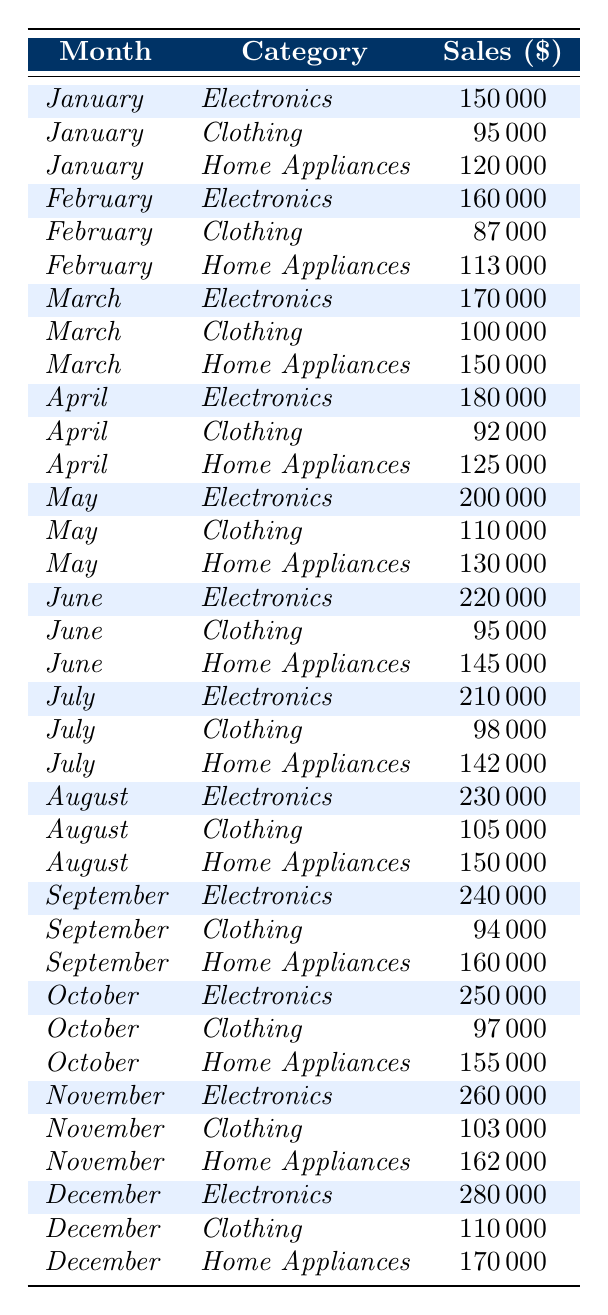What were the total sales for Electronics in June? The sales for Electronics in June are listed in the table as 220,000.
Answer: 220000 What is the sales figure for Home Appliances in December? The sales figure for Home Appliances in December is given as 170,000 according to the table.
Answer: 170000 Which product category had the highest sales in November? Comparing the sales in November, Electronics had 260,000, Clothing had 103,000, and Home Appliances had 162,000. Therefore, Electronics had the highest sales.
Answer: Electronics What were the average sales for Clothing from January to March? The sales figures for Clothing from January to March are 95,000, 87,000, and 100,000. Adding these gives 282,000. The average is 282,000 / 3 = 94,000.
Answer: 94000 Did sales for Home Appliances increase every month throughout the year? Looking at the sales figures for Home Appliances, they were 120,000 in January, 113,000 in February, 150,000 in March, 125,000 in April, 130,000 in May, 145,000 in June, 142,000 in July, 150,000 in August, 160,000 in September, 155,000 in October, 162,000 in November, and 170,000 in December. The sales fluctuate and do not increase every month, indicating a "No" answer.
Answer: No What was the percentage increase in sales for Electronics from July to October? For Electronics, sales were 210,000 in July and increased to 250,000 in October. The difference is 250,000 - 210,000 = 40,000. The percentage increase is (40,000 / 210,000) * 100 = approximately 19.05%.
Answer: 19.05% Which month had the lowest sales for Clothing during 2023, and what was that amount? The sales figures for Clothing are 95,000 in January, 87,000 in February, 100,000 in March, 92,000 in April, 110,000 in May, 95,000 in June, 98,000 in July, 105,000 in August, 94,000 in September, 97,000 in October, 103,000 in November, and 110,000 in December. The lowest sales occurred in February with 87,000.
Answer: February, 87000 Calculate the difference between the total sales of Electronics and Home Appliances in August. The total sales of Electronics in August was 230,000, and for Home Appliances, it was 150,000. The difference is 230,000 - 150,000 = 80,000.
Answer: 80000 Is it true that Clothing sales were consistently below 100,000 until May? The sales figures for Clothing in January (95,000), February (87,000), March (100,000), and April (92,000). January, February, and April are below 100,000, while March is exactly 100,000. Therefore, it is not true as March is not below.
Answer: No What was the highest sales figure for any product category in 2023, and which category achieved it? The highest sales figure in the table is 280,000 for Electronics in December.
Answer: 280000, Electronics Determine the total sales for Home Appliances for the entire year (all months combined). Adding the sales for Home Appliances from each month gives: 120,000 + 113,000 + 150,000 + 125,000 + 130,000 + 145,000 + 142,000 + 150,000 + 160,000 + 155,000 + 162,000 + 170,000 = 1,825,000.
Answer: 1825000 